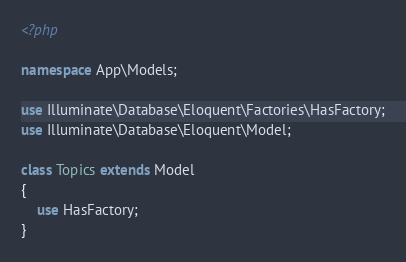<code> <loc_0><loc_0><loc_500><loc_500><_PHP_><?php

namespace App\Models;

use Illuminate\Database\Eloquent\Factories\HasFactory;
use Illuminate\Database\Eloquent\Model;

class Topics extends Model
{
    use HasFactory;
}
</code> 